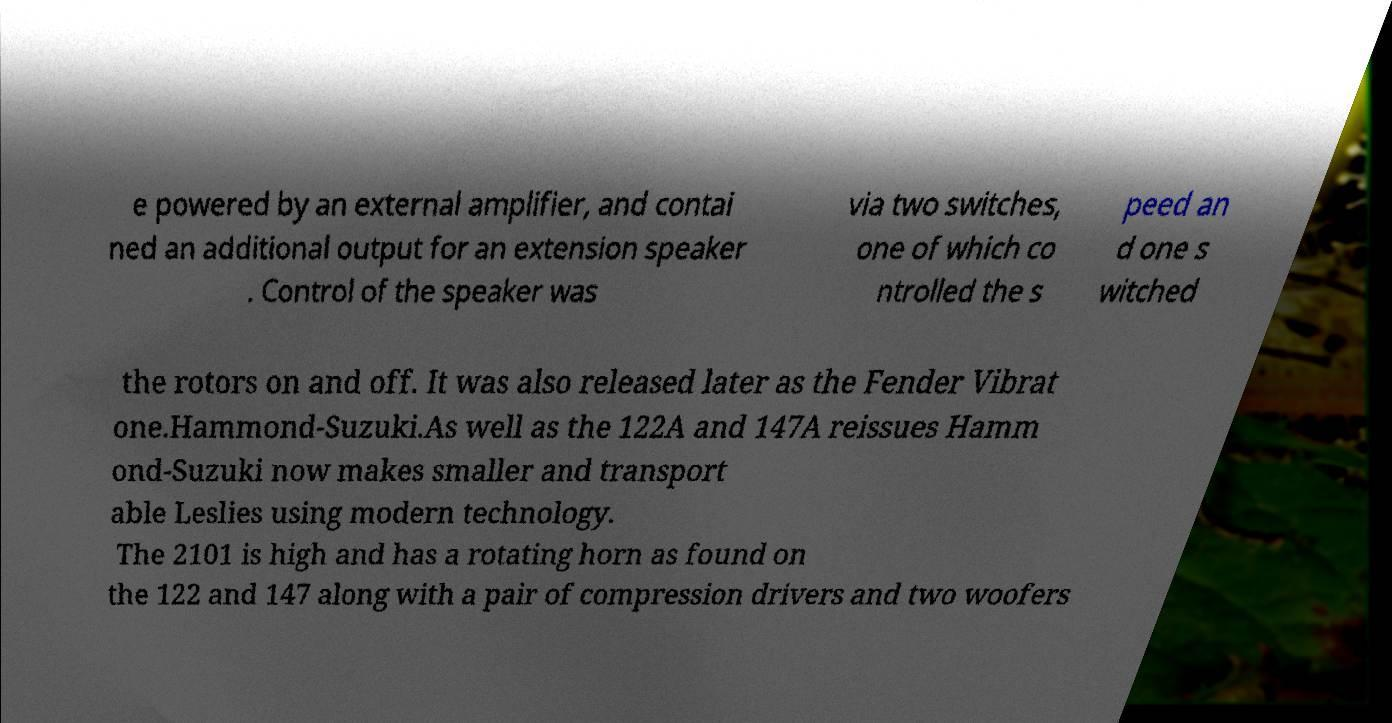Please identify and transcribe the text found in this image. e powered by an external amplifier, and contai ned an additional output for an extension speaker . Control of the speaker was via two switches, one of which co ntrolled the s peed an d one s witched the rotors on and off. It was also released later as the Fender Vibrat one.Hammond-Suzuki.As well as the 122A and 147A reissues Hamm ond-Suzuki now makes smaller and transport able Leslies using modern technology. The 2101 is high and has a rotating horn as found on the 122 and 147 along with a pair of compression drivers and two woofers 